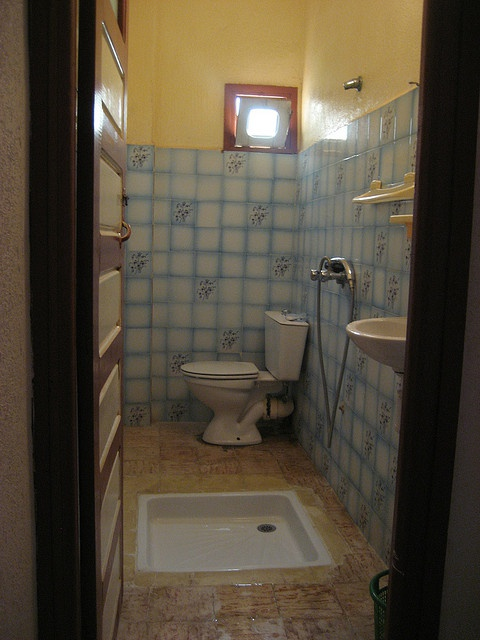Describe the objects in this image and their specific colors. I can see toilet in black and gray tones and sink in black and gray tones in this image. 